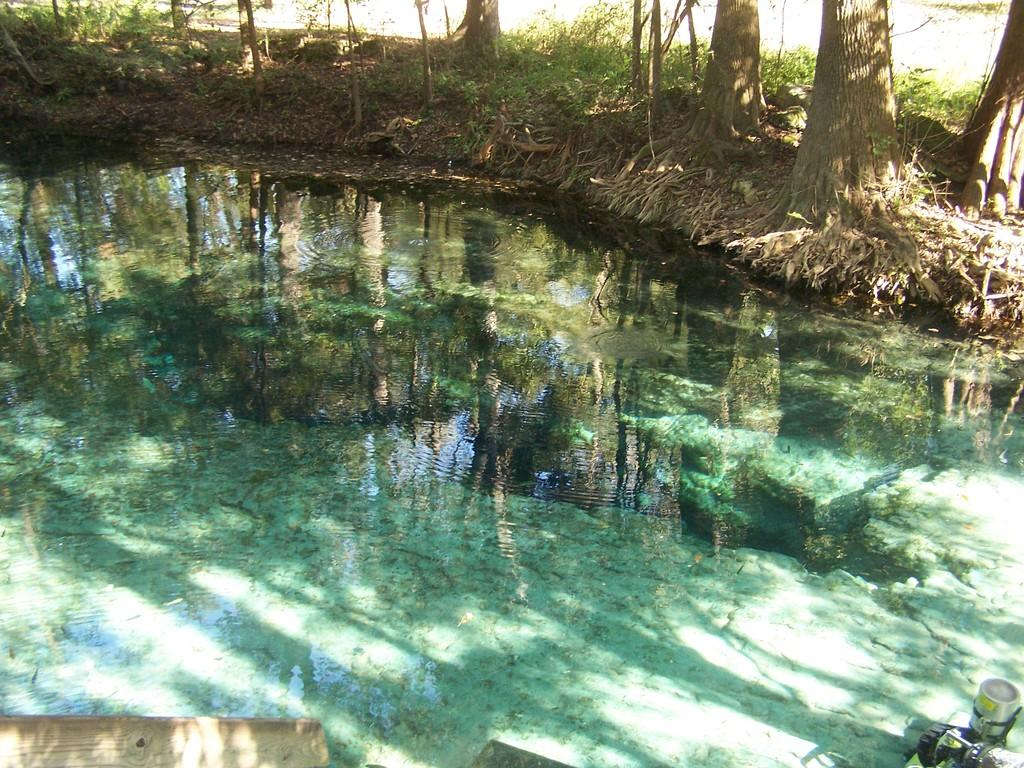What is visible in the image? There is water visible in the image. What can be seen in the background of the image? There is a group of trees in the background of the image. What type of crime is being committed in the image? There is no crime or criminal activity depicted in the image; it features water and a group of trees. What kind of shoes are visible in the image? There are no shoes present in the image. 